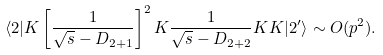Convert formula to latex. <formula><loc_0><loc_0><loc_500><loc_500>\langle 2 | K \left [ \frac { 1 } { \sqrt { s } - D _ { 2 + 1 } } \right ] ^ { 2 } K \frac { 1 } { \sqrt { s } - D _ { 2 + 2 } } K K | 2 ^ { \prime } \rangle \sim O ( p ^ { 2 } ) .</formula> 